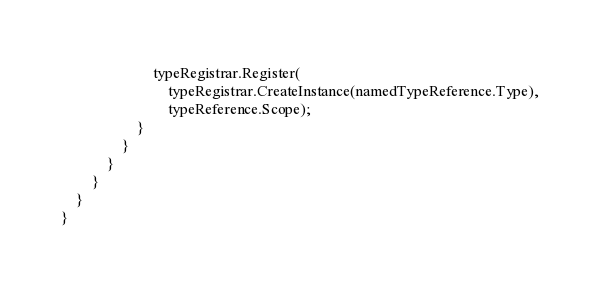Convert code to text. <code><loc_0><loc_0><loc_500><loc_500><_C#_>                        typeRegistrar.Register(
                            typeRegistrar.CreateInstance(namedTypeReference.Type),
                            typeReference.Scope);
                    }
                }
            }
        }
    }
}
</code> 